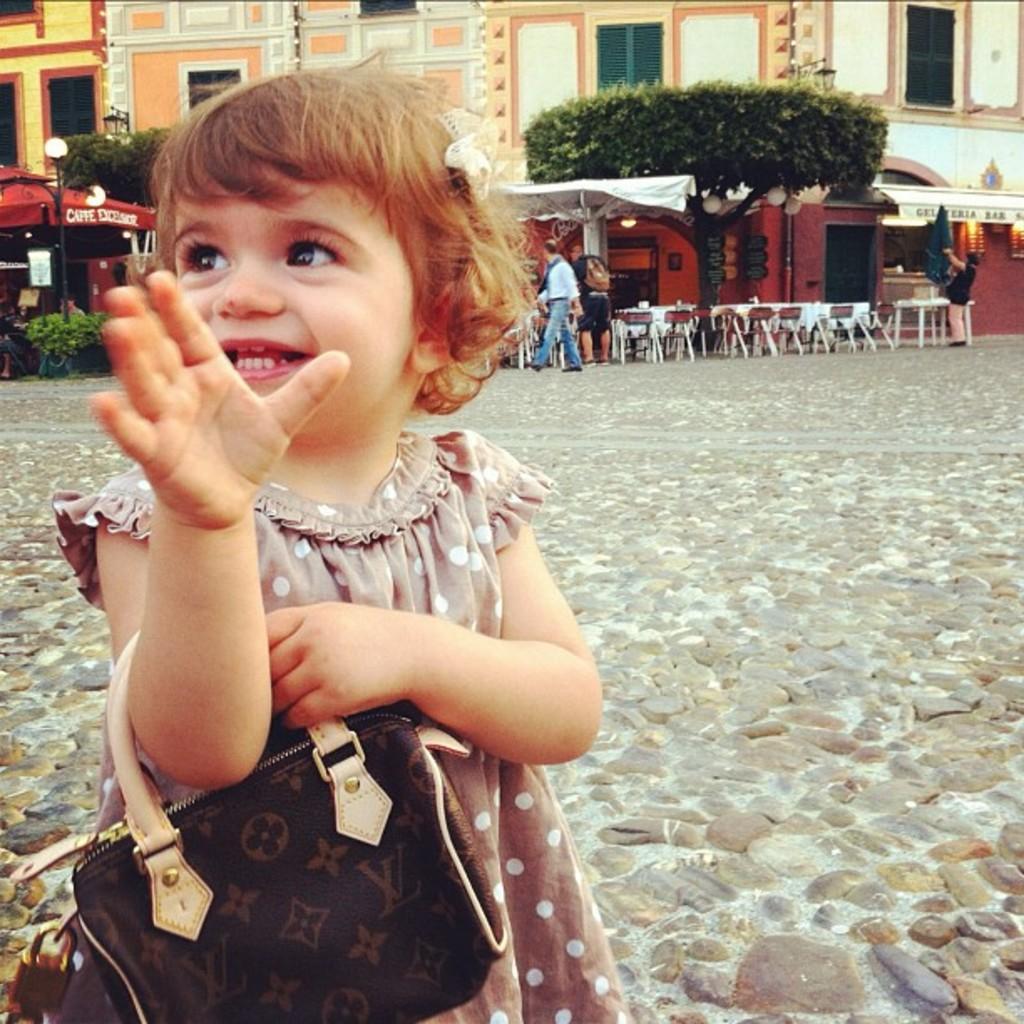Describe this image in one or two sentences. In this picture there is a girl wearing a handbag. There are few chairs and tables. There is a tree and building. There are few people. 